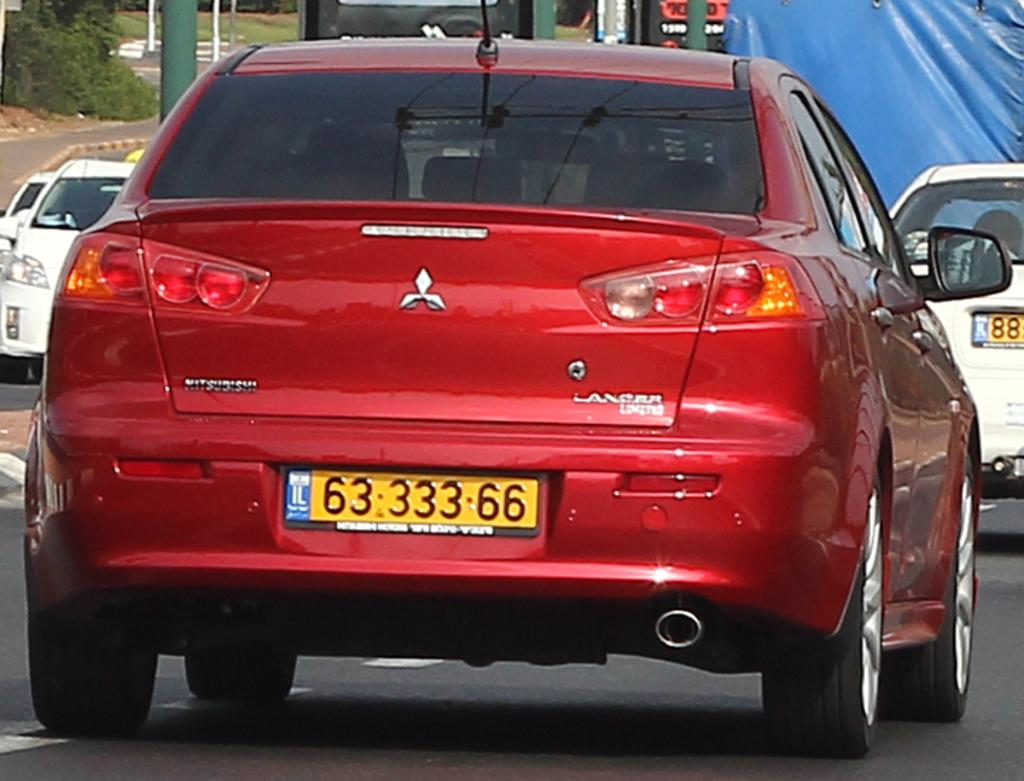<image>
Describe the image concisely. A red car has the number 6333366 on the license plate. 